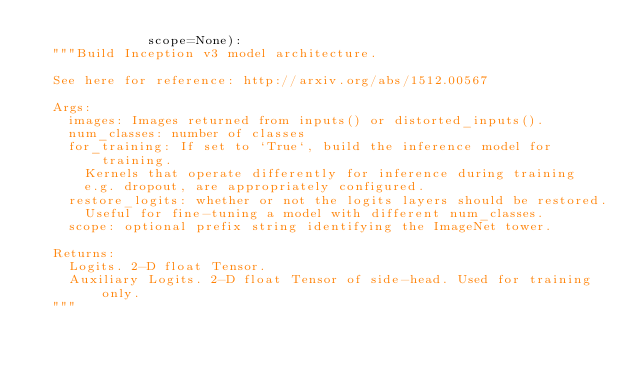<code> <loc_0><loc_0><loc_500><loc_500><_Python_>              scope=None):
  """Build Inception v3 model architecture.

  See here for reference: http://arxiv.org/abs/1512.00567

  Args:
    images: Images returned from inputs() or distorted_inputs().
    num_classes: number of classes
    for_training: If set to `True`, build the inference model for training.
      Kernels that operate differently for inference during training
      e.g. dropout, are appropriately configured.
    restore_logits: whether or not the logits layers should be restored.
      Useful for fine-tuning a model with different num_classes.
    scope: optional prefix string identifying the ImageNet tower.

  Returns:
    Logits. 2-D float Tensor.
    Auxiliary Logits. 2-D float Tensor of side-head. Used for training only.
  """</code> 